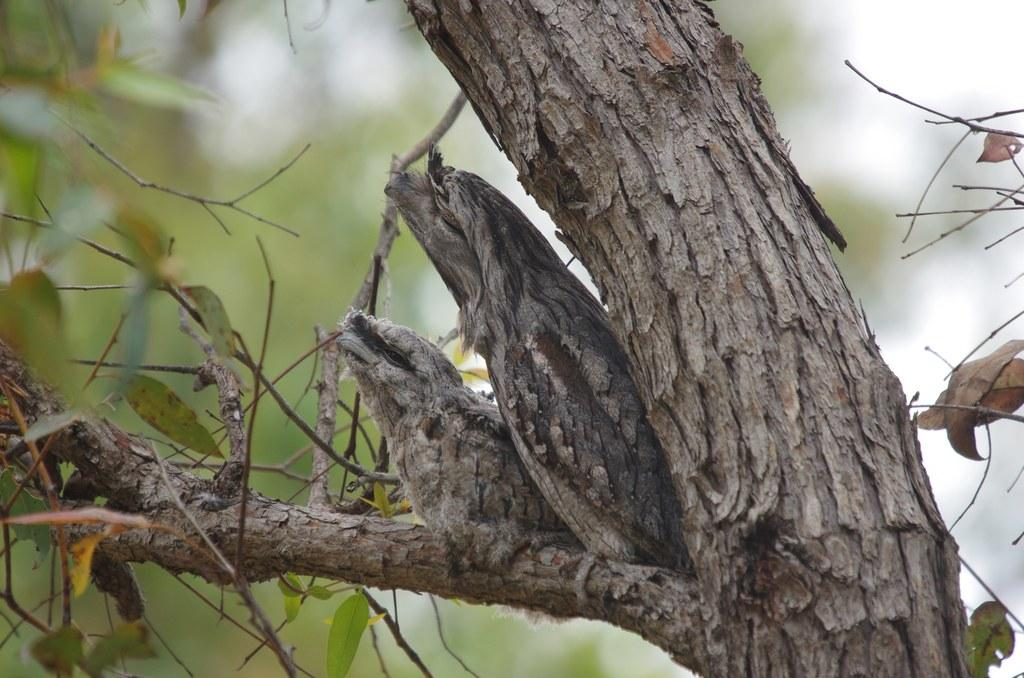What type of animals can be seen in the image? There are birds in the image. Where are the birds located? The birds are on the branch of a tree. Can you describe the background of the image? The background of the image is blurred. What word is written on the branch where the birds are sitting? There is no word written on the branch in the image; it only shows birds sitting on a tree branch. 